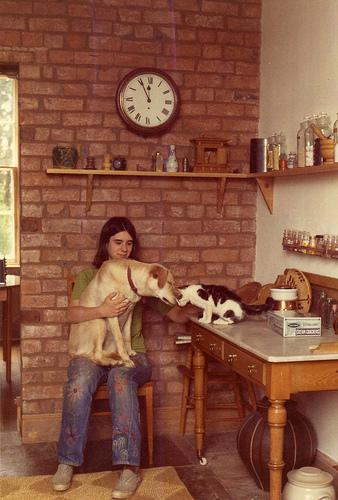Question: why is the kid holding the dog?
Choices:
A. To hug.
B. To hold.
C. To train.
D. To see the cat.
Answer with the letter. Answer: D Question: what color shirt is the kid wearing?
Choices:
A. Green.
B. Blue.
C. Yellow.
D. White.
Answer with the letter. Answer: A Question: what color shoes is the kids wearing?
Choices:
A. Black.
B. White.
C. Red.
D. Brown.
Answer with the letter. Answer: B Question: what is the kid doing?
Choices:
A. Sitting down.
B. Playing.
C. Drawing.
D. Singing.
Answer with the letter. Answer: A Question: how many animals in the picture?
Choices:
A. Two.
B. Three.
C. One.
D. Five.
Answer with the letter. Answer: A Question: who is holding the dog?
Choices:
A. A boy.
B. A woman.
C. A man.
D. An old man.
Answer with the letter. Answer: A 